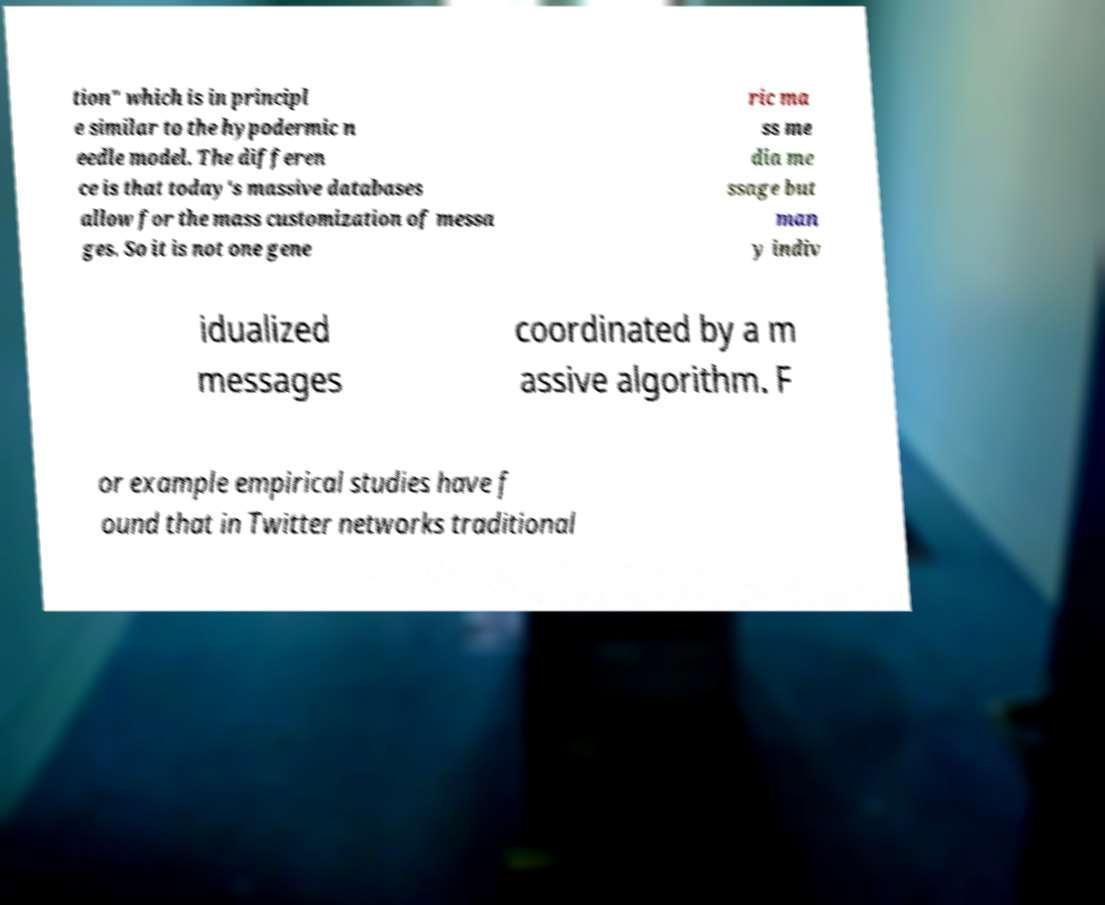I need the written content from this picture converted into text. Can you do that? tion" which is in principl e similar to the hypodermic n eedle model. The differen ce is that today's massive databases allow for the mass customization of messa ges. So it is not one gene ric ma ss me dia me ssage but man y indiv idualized messages coordinated by a m assive algorithm. F or example empirical studies have f ound that in Twitter networks traditional 